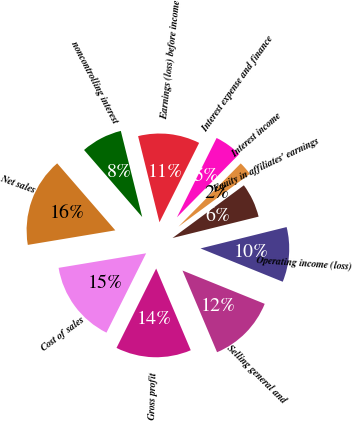<chart> <loc_0><loc_0><loc_500><loc_500><pie_chart><fcel>Net sales<fcel>Cost of sales<fcel>Gross profit<fcel>Selling general and<fcel>Operating income (loss)<fcel>Equity in affiliates' earnings<fcel>Interest income<fcel>Interest expense and finance<fcel>Earnings (loss) before income<fcel>noncontrolling interest<nl><fcel>16.25%<fcel>15.0%<fcel>13.75%<fcel>12.5%<fcel>10.0%<fcel>6.25%<fcel>2.5%<fcel>5.0%<fcel>11.25%<fcel>7.5%<nl></chart> 